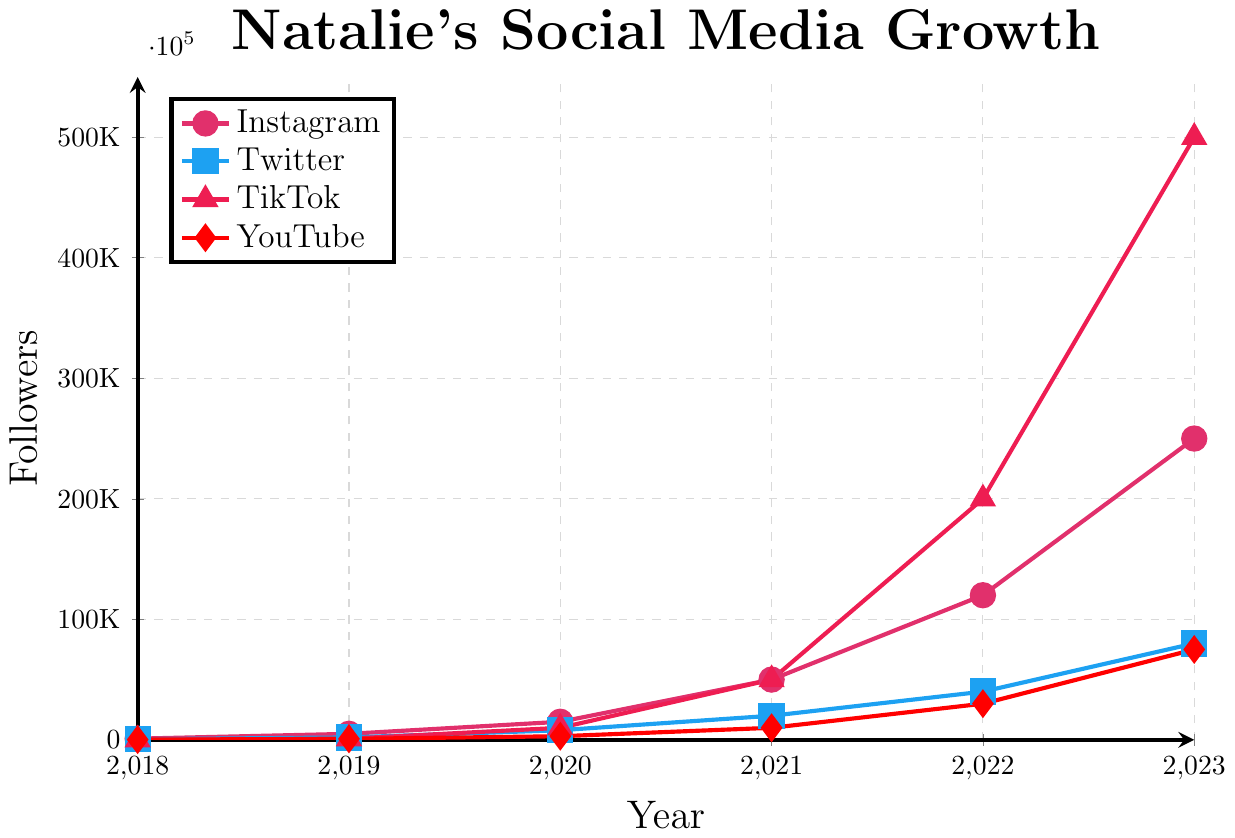Which platform had the most followers in 2023? By looking at the data points for each platform in 2023, we can see that TikTok has the highest number of followers, reaching 500,000.
Answer: TikTok What is the total number of followers across all platforms in 2021? For 2021: Instagram has 50,000, Twitter has 20,000, TikTok has 50,000, and YouTube has 10,000. Summing these up: 50,000 + 20,000 + 50,000 + 10,000 = 130,000.
Answer: 130,000 How did Natalie's YouTube growth from 2019 to 2023 compare with her Twitter growth in the same period? YouTube followers went from 800 to 75,000, a difference of 74,200. Twitter followers went from 2,000 to 80,000, a difference of 78,000. Comparing 74,200 and 78,000, Twitter had a larger growth.
Answer: Twitter had a larger growth Which platform showed the highest percentage increase in followers from 2018 to 2019? Calculate percentage increase for each platform: 
Instagram: (5000 - 1000) / 1000 * 100 = 400%
Twitter: (2000 - 500) / 500 * 100 = 300%
TikTok: (1000 - 0) / 0 * 100 = Undefined (since no followers in 2018)
YouTube: (800 - 200) / 200 * 100 = 300%
So, Instagram had the highest percent increase.
Answer: Instagram Between which years did TikTok see the most significant growth in raw numbers? Check differences year by year: 
2019-2020: 10,000 - 1,000 = 9,000
2020-2021: 50,000 - 10,000 = 40,000
2021-2022: 200,000 - 50,000 = 150,000
2022-2023: 500,000 - 200,000 = 300,000
The most significant growth is between 2022-2023 with an increase of 300,000.
Answer: 2022-2023 What was the average number of followers for Instagram from 2018 to 2023? Sum up the followers for Instagram from 2018 to 2023 and then divide by the number of years: 
(1000 + 5000 + 15000 + 50000 + 120000 + 250000) / 6 = 88,500
Answer: 88,500 Did any platform have a year where follower growth decreased compared to the previous year? By examining the data, we see that there is no year where the follower count for any platform decreased compared to the previous year.
Answer: No Which year did Natalie see the biggest combined follower increase across all platforms compared to the previous year? Calculate the total increase for each year:
2019: (5000 - 1000) + (2000 - 500) + (1000 - 0) + (800 - 200) = 6700
2020: (15000 - 5000) + (8000 - 2000) + (10000 - 1000) + (3000 - 800) = 22800
2021: (50000 - 15000) + (20000 - 8000) + (50000 - 10000) + (10000 - 3000) = 91000
2022: (120000 - 50000) + (40000 - 20000) + (200000 - 50000) + (30000 - 10000) = 180000 
2023: (250000 - 120000) + (80000 - 40000) + (500000 - 200000) + (75000 - 30000) = 375000
The year with the biggest combined increase is 2023 with 375,000.
Answer: 2023 